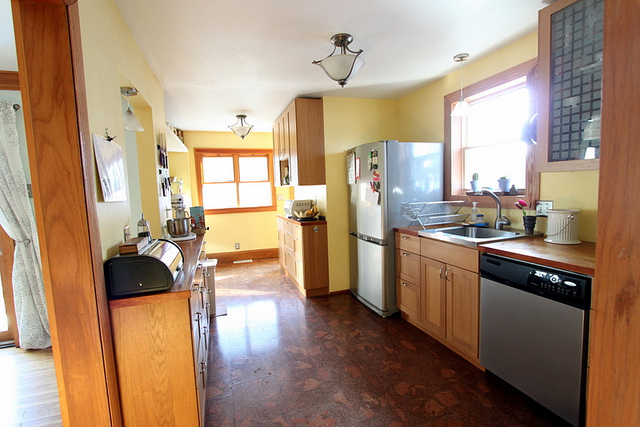What material is the floor made of? The floor is covered with large, rectangular ceramic tiles, showcasing a brown and tan marbled effect. 